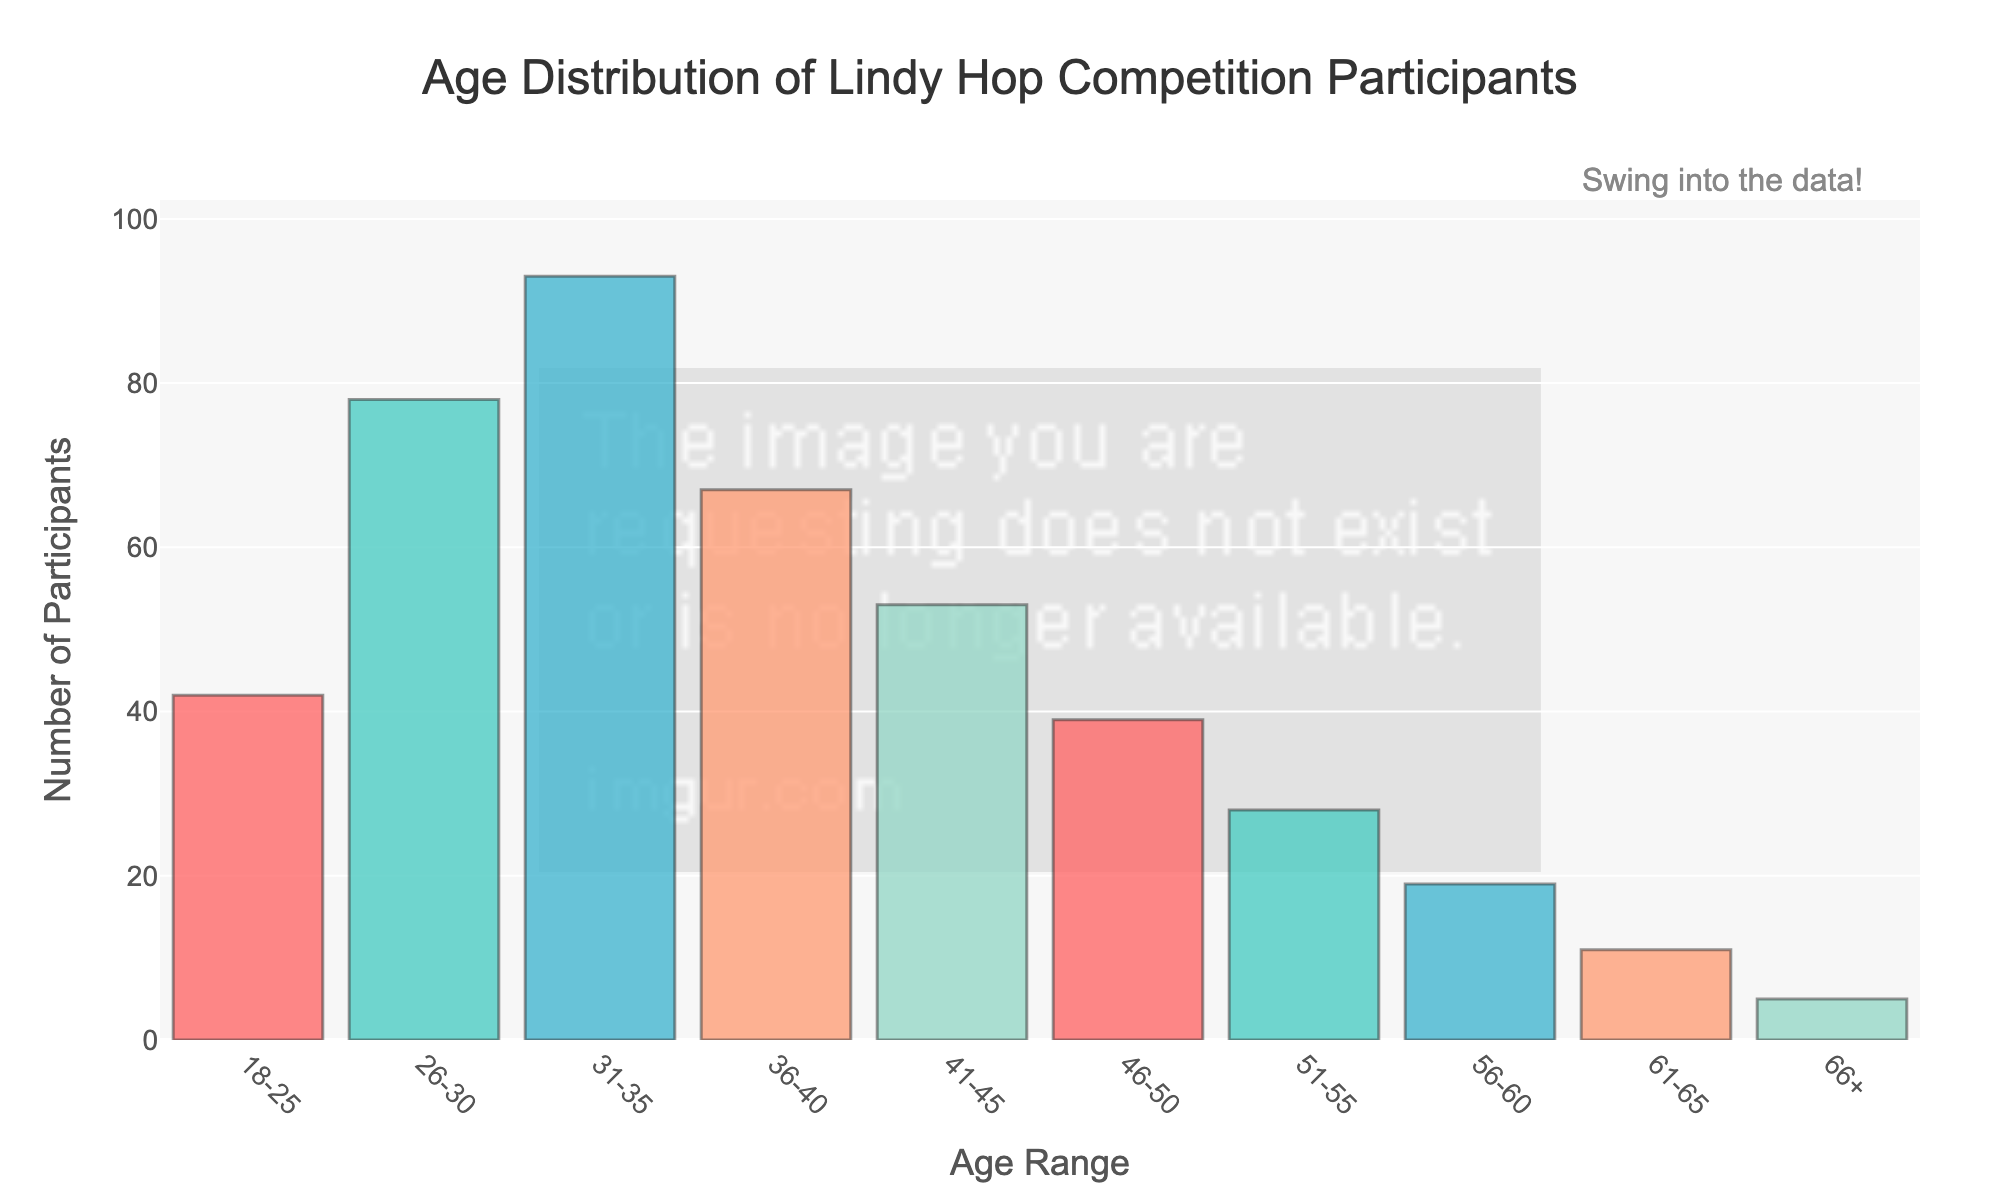What is the title of the histogram? The title is usually found at the top of the plot and gives an overview of the data being visualized. Here, it states "Age Distribution of Lindy Hop Competition Participants".
Answer: Age Distribution of Lindy Hop Competition Participants What is the age range with the highest number of participants? By observing the height of the bars, the tallest bar represents the age range with the highest number of participants.
Answer: 31-35 Which age range has the least number of participants? The smallest bar represents the age range with the fewest participants.
Answer: 66+ How many age ranges are represented in the histogram? Count the number of bars or age range labels on the x-axis.
Answer: 10 What is the total number of participants in the age ranges 41-45 and 46-50 combined? Add the number of participants in the 41-45 range (53) and the 46-50 range (39).
Answer: 92 What is the difference in the number of participants between the 31-35 age range and the 61-65 age range? Subtract the number of participants in the 61-65 range (11) from the number of participants in the 31-35 range (93).
Answer: 82 How many more participants are there in the 26-30 age range compared to the 18-25 age range? Subtract the number of participants in the 18-25 range (42) from the 26-30 range (78).
Answer: 36 What is the combined number of participants in the age ranges from 36-40 to 51-55? Add the number of participants in each of the age ranges from 36-40 (67), 41-45 (53), 46-50 (39), and 51-55 (28).
Answer: 187 Which age range shows a significant drop in participants compared to its preceding range, indicating a potential decrease in participation with age? Compare the number of participants in successive age ranges and identify the age range where there is a notable decrease in the number of participants. The biggest drop occurs between the 31-35 range (93) and 36-40 range (67).
Answer: 36-40 What is the average number of participants for all age ranges shown in the histogram? Sum the number of participants in all age ranges and divide by the number of age ranges (Total: 435, Age Ranges: 10). Calculation: 435/10.
Answer: 43.5 